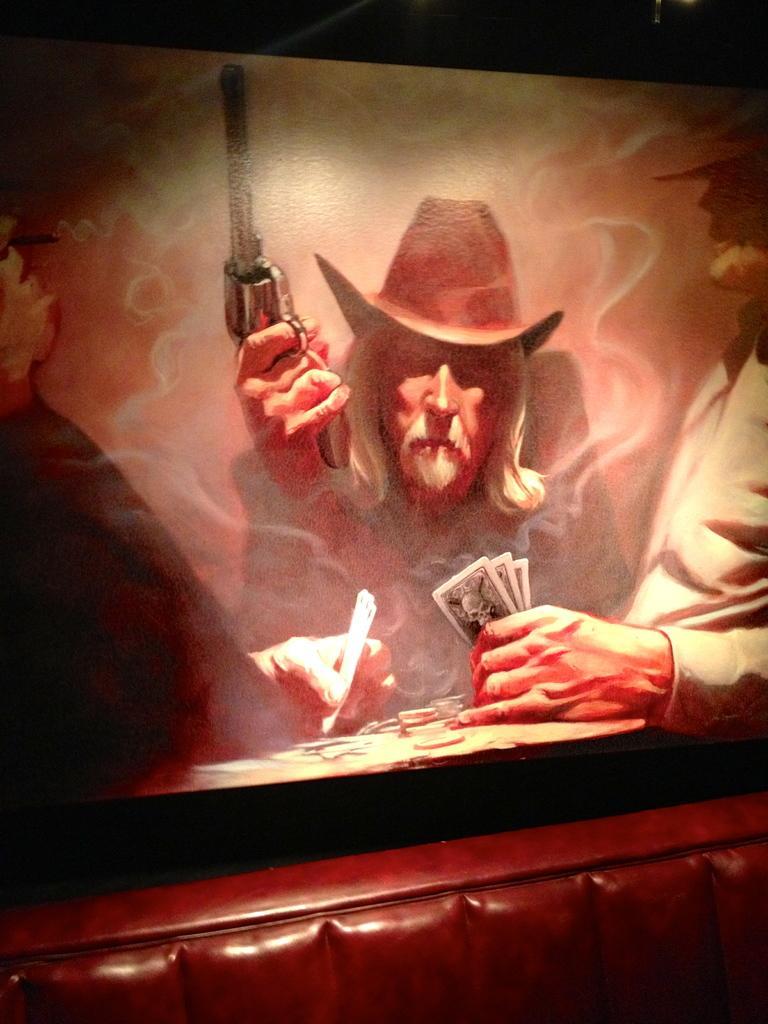Please provide a concise description of this image. In the foreground of this picture we can see an object seems to be the couch. In the background we can see an object which seems to be the painting and we can see the two persons holding some objects and another person holding a rifle in the painting. The background of the image is dark. 